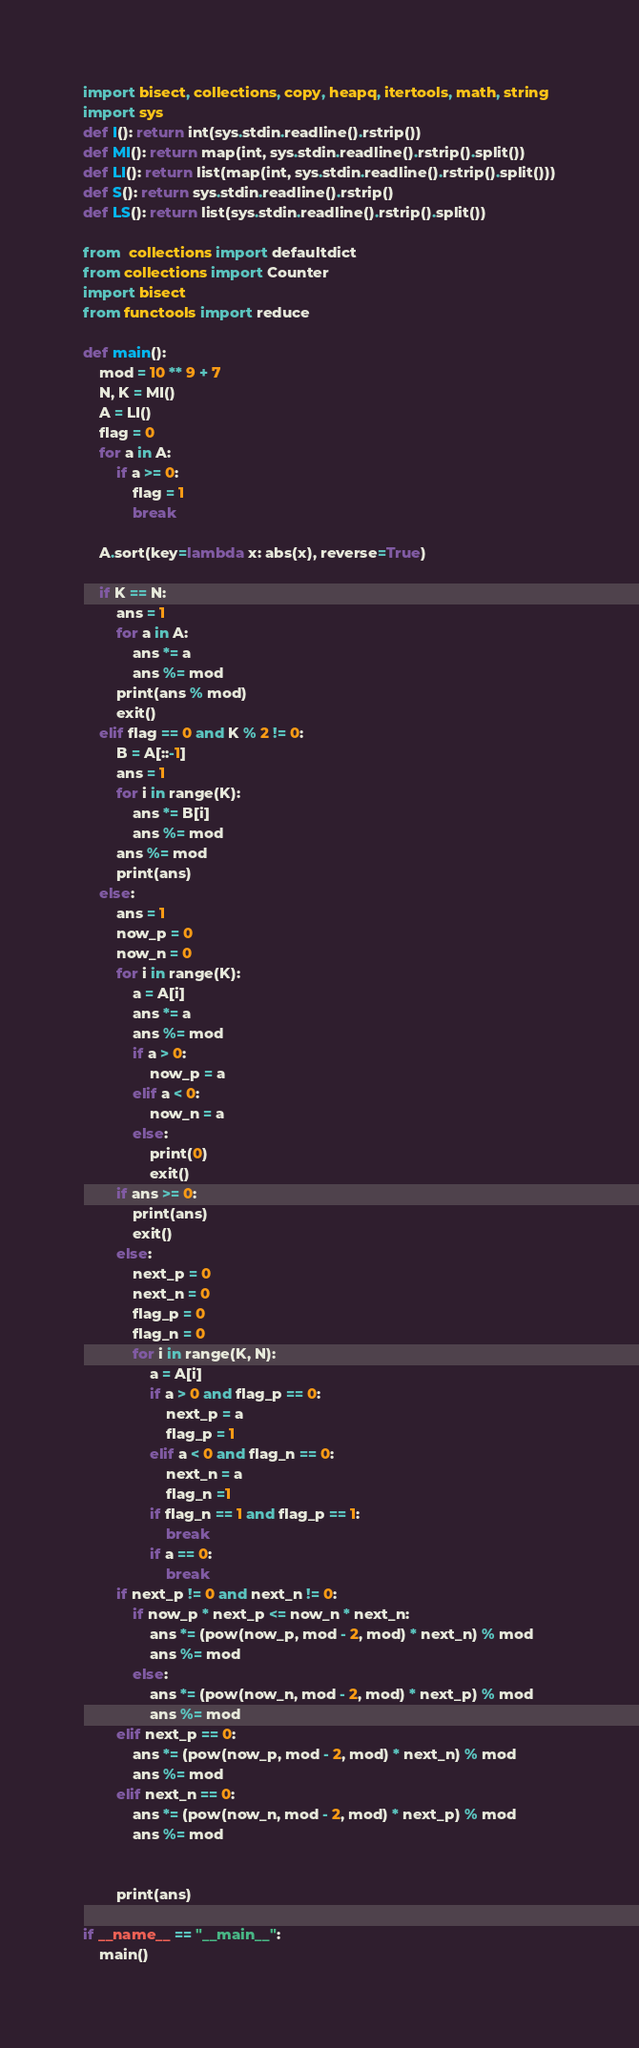Convert code to text. <code><loc_0><loc_0><loc_500><loc_500><_Python_>import bisect, collections, copy, heapq, itertools, math, string
import sys
def I(): return int(sys.stdin.readline().rstrip())
def MI(): return map(int, sys.stdin.readline().rstrip().split())
def LI(): return list(map(int, sys.stdin.readline().rstrip().split()))
def S(): return sys.stdin.readline().rstrip()
def LS(): return list(sys.stdin.readline().rstrip().split())

from  collections import defaultdict
from collections import Counter
import bisect
from functools import reduce

def main():
    mod = 10 ** 9 + 7
    N, K = MI()
    A = LI()
    flag = 0
    for a in A:
        if a >= 0:
            flag = 1
            break

    A.sort(key=lambda x: abs(x), reverse=True)

    if K == N:
        ans = 1
        for a in A:
            ans *= a
            ans %= mod
        print(ans % mod)
        exit()
    elif flag == 0 and K % 2 != 0:
        B = A[::-1]
        ans = 1
        for i in range(K):
            ans *= B[i]
            ans %= mod
        ans %= mod
        print(ans)
    else:
        ans = 1
        now_p = 0
        now_n = 0
        for i in range(K):
            a = A[i]
            ans *= a
            ans %= mod
            if a > 0:
                now_p = a
            elif a < 0:
                now_n = a
            else:
                print(0)
                exit()
        if ans >= 0:
            print(ans)
            exit()
        else:
            next_p = 0
            next_n = 0
            flag_p = 0
            flag_n = 0
            for i in range(K, N):
                a = A[i]
                if a > 0 and flag_p == 0:
                    next_p = a
                    flag_p = 1
                elif a < 0 and flag_n == 0:
                    next_n = a
                    flag_n =1
                if flag_n == 1 and flag_p == 1:
                    break
                if a == 0:
                    break
        if next_p != 0 and next_n != 0:
            if now_p * next_p <= now_n * next_n:
                ans *= (pow(now_p, mod - 2, mod) * next_n) % mod
                ans %= mod
            else:
                ans *= (pow(now_n, mod - 2, mod) * next_p) % mod
                ans %= mod
        elif next_p == 0:
            ans *= (pow(now_p, mod - 2, mod) * next_n) % mod
            ans %= mod
        elif next_n == 0:
            ans *= (pow(now_n, mod - 2, mod) * next_p) % mod
            ans %= mod


        print(ans)

if __name__ == "__main__":
    main()
</code> 